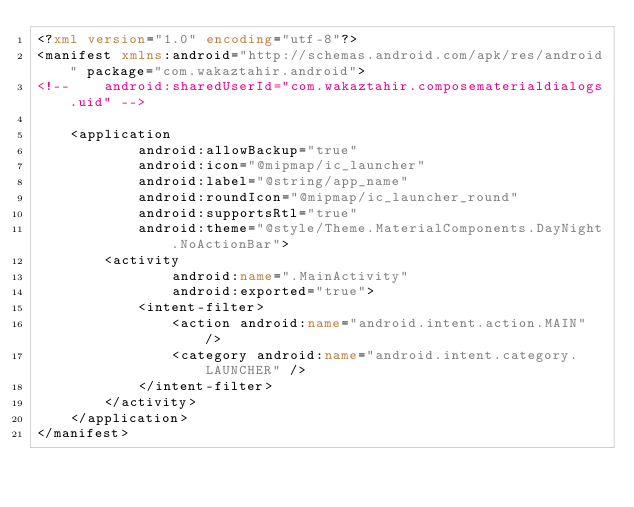<code> <loc_0><loc_0><loc_500><loc_500><_XML_><?xml version="1.0" encoding="utf-8"?>
<manifest xmlns:android="http://schemas.android.com/apk/res/android" package="com.wakaztahir.android">
<!--    android:sharedUserId="com.wakaztahir.composematerialdialogs.uid" -->

    <application
            android:allowBackup="true"
            android:icon="@mipmap/ic_launcher"
            android:label="@string/app_name"
            android:roundIcon="@mipmap/ic_launcher_round"
            android:supportsRtl="true"
            android:theme="@style/Theme.MaterialComponents.DayNight.NoActionBar">
        <activity
                android:name=".MainActivity"
                android:exported="true">
            <intent-filter>
                <action android:name="android.intent.action.MAIN" />
                <category android:name="android.intent.category.LAUNCHER" />
            </intent-filter>
        </activity>
    </application>
</manifest></code> 